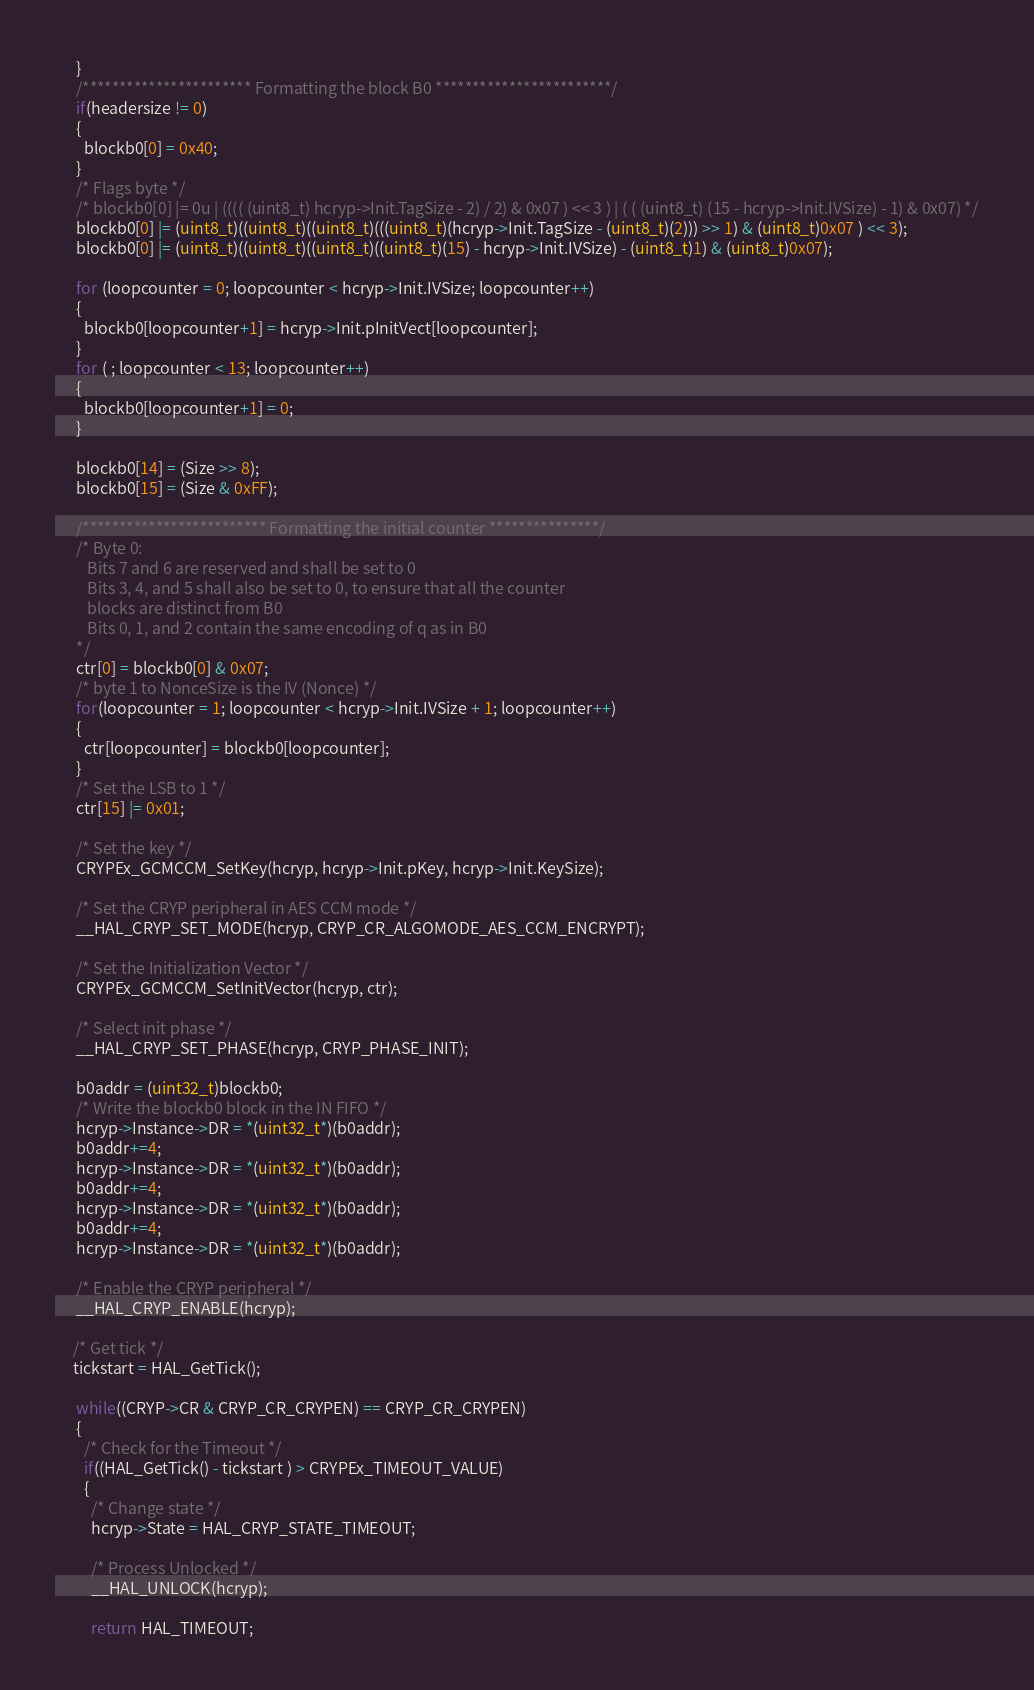Convert code to text. <code><loc_0><loc_0><loc_500><loc_500><_C_>      }
      /*********************** Formatting the block B0 ************************/
      if(headersize != 0)
      {
        blockb0[0] = 0x40;
      }
      /* Flags byte */
      /* blockb0[0] |= 0u | (((( (uint8_t) hcryp->Init.TagSize - 2) / 2) & 0x07 ) << 3 ) | ( ( (uint8_t) (15 - hcryp->Init.IVSize) - 1) & 0x07) */
      blockb0[0] |= (uint8_t)((uint8_t)((uint8_t)(((uint8_t)(hcryp->Init.TagSize - (uint8_t)(2))) >> 1) & (uint8_t)0x07 ) << 3);
      blockb0[0] |= (uint8_t)((uint8_t)((uint8_t)((uint8_t)(15) - hcryp->Init.IVSize) - (uint8_t)1) & (uint8_t)0x07);
      
      for (loopcounter = 0; loopcounter < hcryp->Init.IVSize; loopcounter++)
      {
        blockb0[loopcounter+1] = hcryp->Init.pInitVect[loopcounter];
      }
      for ( ; loopcounter < 13; loopcounter++)
      {
        blockb0[loopcounter+1] = 0;
      }
      
      blockb0[14] = (Size >> 8);
      blockb0[15] = (Size & 0xFF);
      
      /************************* Formatting the initial counter ***************/
      /* Byte 0:
         Bits 7 and 6 are reserved and shall be set to 0
         Bits 3, 4, and 5 shall also be set to 0, to ensure that all the counter 
         blocks are distinct from B0
         Bits 0, 1, and 2 contain the same encoding of q as in B0
      */
      ctr[0] = blockb0[0] & 0x07;
      /* byte 1 to NonceSize is the IV (Nonce) */
      for(loopcounter = 1; loopcounter < hcryp->Init.IVSize + 1; loopcounter++)
      {
        ctr[loopcounter] = blockb0[loopcounter];
      }
      /* Set the LSB to 1 */
      ctr[15] |= 0x01;
      
      /* Set the key */
      CRYPEx_GCMCCM_SetKey(hcryp, hcryp->Init.pKey, hcryp->Init.KeySize);
      
      /* Set the CRYP peripheral in AES CCM mode */
      __HAL_CRYP_SET_MODE(hcryp, CRYP_CR_ALGOMODE_AES_CCM_ENCRYPT);
      
      /* Set the Initialization Vector */
      CRYPEx_GCMCCM_SetInitVector(hcryp, ctr);
      
      /* Select init phase */
      __HAL_CRYP_SET_PHASE(hcryp, CRYP_PHASE_INIT);
      
      b0addr = (uint32_t)blockb0;
      /* Write the blockb0 block in the IN FIFO */
      hcryp->Instance->DR = *(uint32_t*)(b0addr);
      b0addr+=4;
      hcryp->Instance->DR = *(uint32_t*)(b0addr);
      b0addr+=4;
      hcryp->Instance->DR = *(uint32_t*)(b0addr);
      b0addr+=4;
      hcryp->Instance->DR = *(uint32_t*)(b0addr);
      
      /* Enable the CRYP peripheral */
      __HAL_CRYP_ENABLE(hcryp);
      
     /* Get tick */
     tickstart = HAL_GetTick();

      while((CRYP->CR & CRYP_CR_CRYPEN) == CRYP_CR_CRYPEN)
      {
        /* Check for the Timeout */
        if((HAL_GetTick() - tickstart ) > CRYPEx_TIMEOUT_VALUE)
        {
          /* Change state */
          hcryp->State = HAL_CRYP_STATE_TIMEOUT;
          
          /* Process Unlocked */
          __HAL_UNLOCK(hcryp);
          
          return HAL_TIMEOUT;</code> 